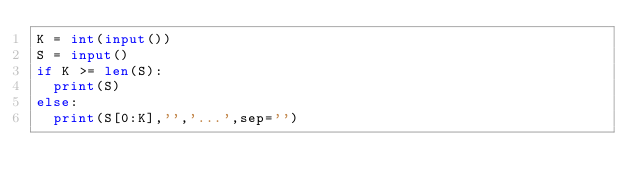Convert code to text. <code><loc_0><loc_0><loc_500><loc_500><_Python_>K = int(input())
S = input()
if K >= len(S):
  print(S)
else:
  print(S[0:K],'','...',sep='')</code> 